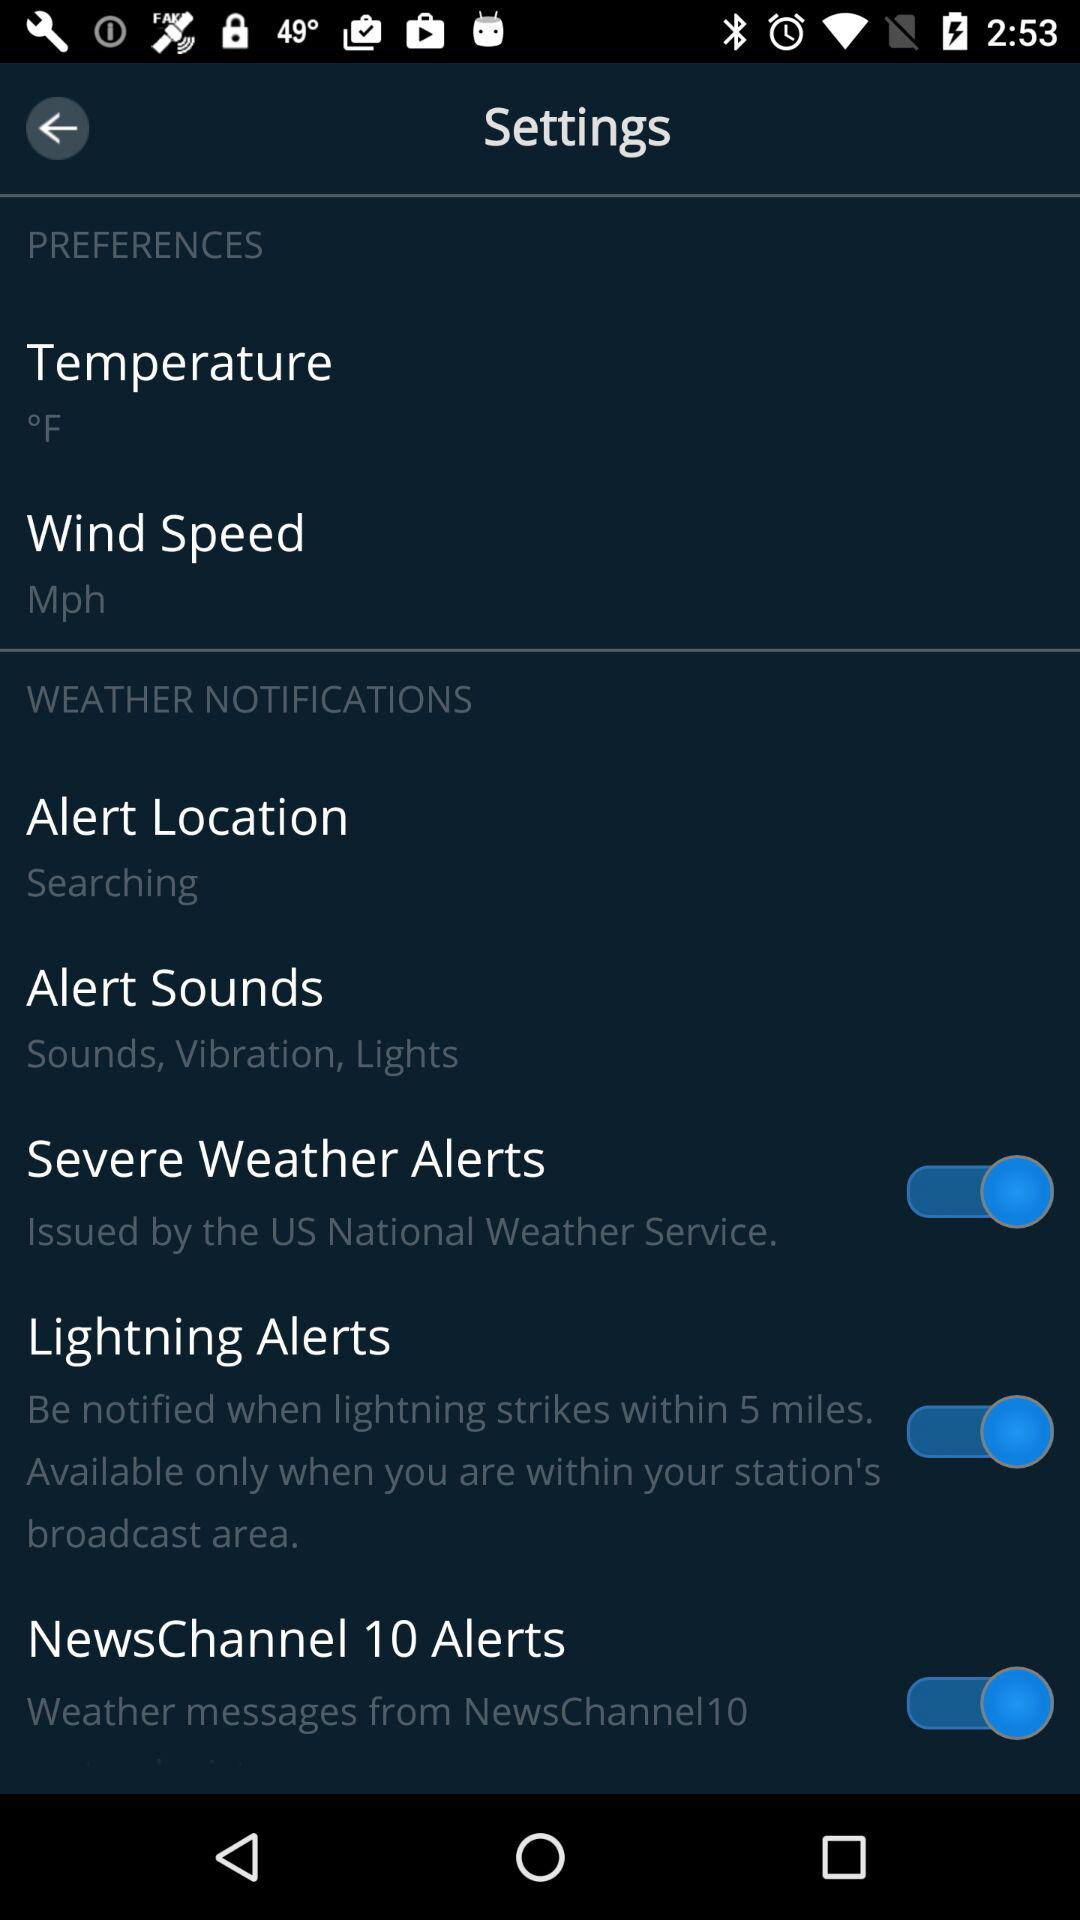What is the mentioned unit of the temperature? The mentioned unit of temperature is °F. 